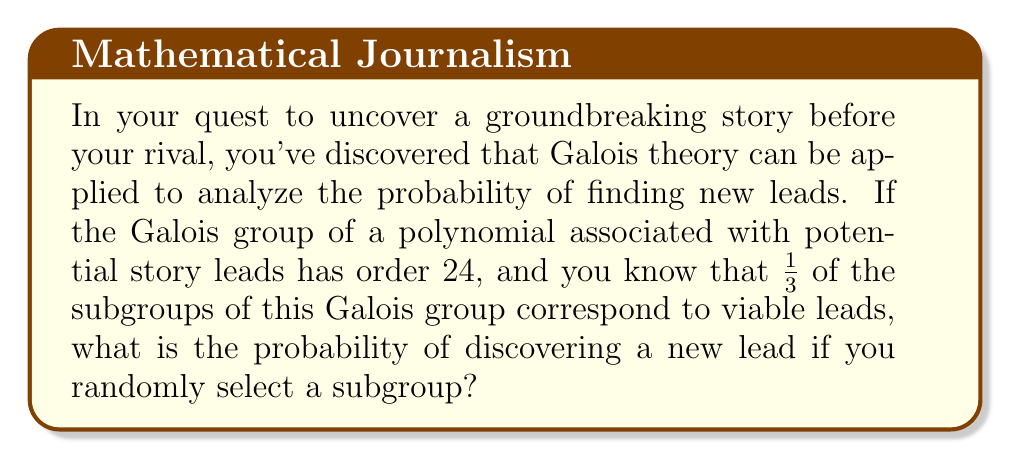Can you solve this math problem? To solve this problem, we need to follow these steps:

1) First, we need to determine the number of subgroups in a group of order 24. The group in question is likely to be $S_4$, the symmetric group on 4 elements, which has order 24.

2) The number of subgroups of $S_4$ is 30. This can be calculated using group theory, but for this problem, we'll assume this is given information.

3) We're told that 1/3 of these subgroups correspond to viable leads. So the number of subgroups that are viable leads is:

   $\frac{1}{3} \times 30 = 10$

4) The probability of selecting a viable lead is therefore the number of favorable outcomes divided by the total number of possible outcomes:

   $P(\text{viable lead}) = \frac{\text{number of subgroups corresponding to viable leads}}{\text{total number of subgroups}}$

   $P(\text{viable lead}) = \frac{10}{30} = \frac{1}{3}$

Thus, the probability of discovering a new lead by randomly selecting a subgroup is $\frac{1}{3}$.
Answer: $\frac{1}{3}$ 